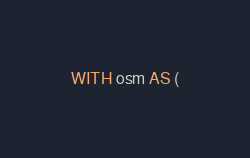Convert code to text. <code><loc_0><loc_0><loc_500><loc_500><_SQL_>
WITH osm AS (</code> 